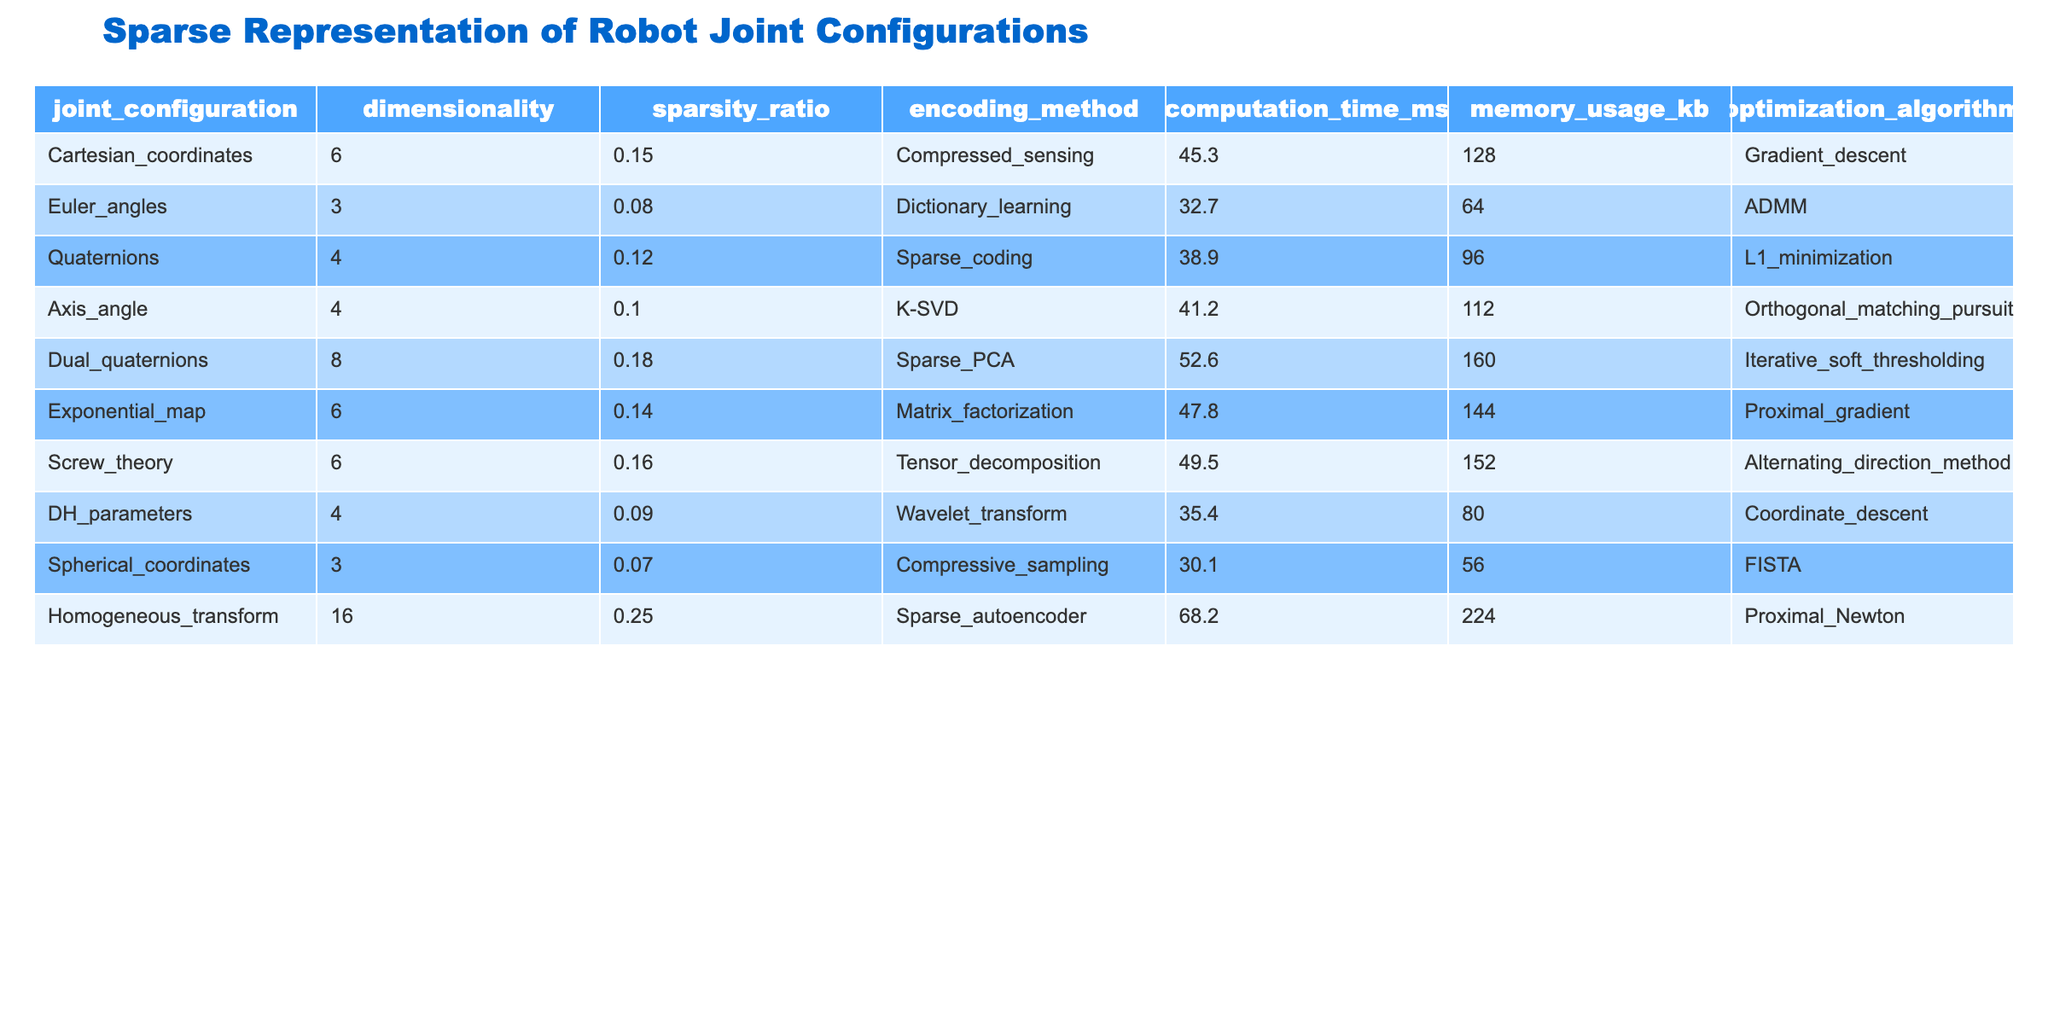What is the dimensionality of the "Homogeneous_transform" joint configuration? The dimensionality is listed directly in the table under the "dimensionality" column for "Homogeneous_transform". It shows a value of 16.
Answer: 16 What is the sparsity ratio of the "Spherical_coordinates" configuration? The sparsity ratio can be found in the "sparsity_ratio" column corresponding to "Spherical_coordinates". It shows a ratio of 0.07.
Answer: 0.07 Which encoding method has the highest computation time? By comparing the "computation_time_ms" column for all configurations, "Homogeneous_transform" has the highest computation time at 68.2 ms.
Answer: Sparse_autoencoder What is the average memory usage of the encoding methods? Summing all the memory usage values (128 + 64 + 96 + 112 + 160 + 144 + 152 + 80 + 56 + 224 = 1,056) gives a total of 1,056. Dividing this by 10 (the number of configurations) gives an average of 105.6.
Answer: 105.6 Is the "Quaternions" encoding method more memory efficient than "Euler_angles"? Comparing their memory usage, "Quaternions" uses 96 kb and "Euler_angles" uses 64 kb. Since 96 > 64, "Quaternions" is not more memory efficient.
Answer: No Which optimization algorithm is used for the "Axis_angle" encoding method? The table shows the optimization algorithm corresponding to "Axis_angle" in the "optimization_algorithm" column, which is "Orthogonal_matching_pursuit".
Answer: Orthogonal_matching_pursuit What is the relationship between the dimensionality and the sparsity ratio for the configurations using "Sparse_coding"? "Sparse_coding" is used by "Quaternions" (dimensionality 4) and has a sparsity ratio of 0.12. Compared to the other configurations, this indicates a moderate level of sparsity for its dimensionality.
Answer: Moderate sparsity for dimensionality 4 How does the computation time for "Dual_quaternions" compare to "Screw_theory"? "Dual_quaternions" has a computation time of 52.6 ms while "Screw_theory" has a computation time of 49.5 ms. Therefore, "Dual_quaternions" has a longer computation time.
Answer: Longer Which joint configuration has the lowest sparsity ratio? By examining the "sparsity_ratio" column, "Spherical_coordinates" has the lowest value of 0.07.
Answer: Spherical_coordinates What is the sum of the computation times for the two configurations with the highest dimensionality? The highest dimensionality is 16 for "Homogeneous_transform" and the next highest is 8 for "Dual_quaternions". Adding their computation times (68.2 + 52.6 = 120.8) gives a total of 120.8 ms.
Answer: 120.8 